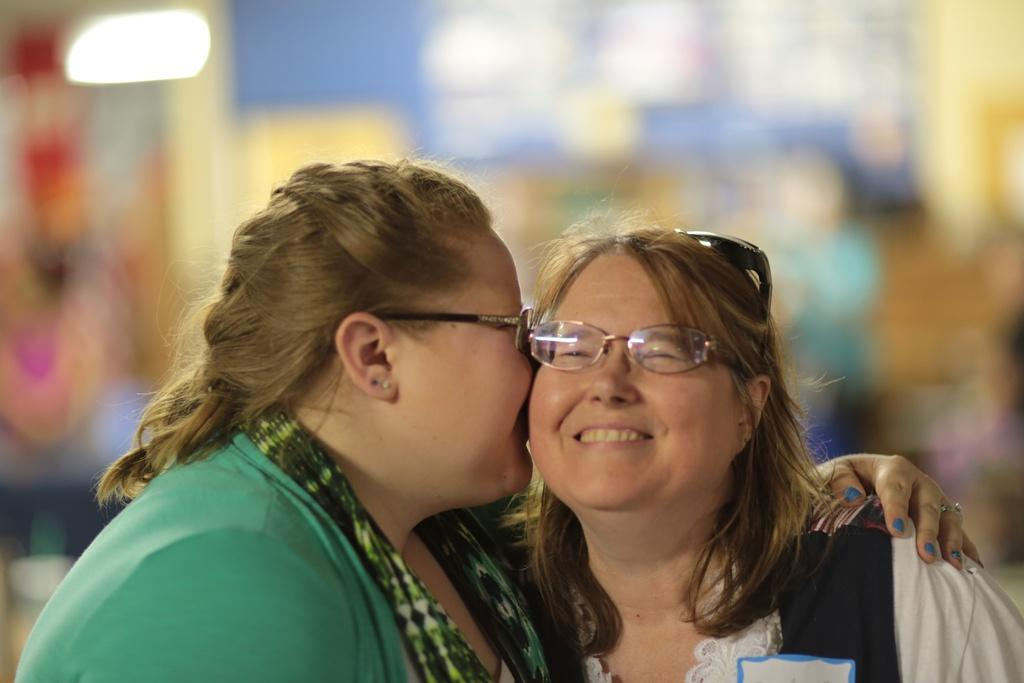Who is present in the image? There are women in the image. What are the women doing in the image? The women are standing and smiling. Can you describe the background of the image? The background of the image is blurry. What type of pig can be seen in the image? There is no pig present in the image. Who is the representative of the group in the image? The image does not indicate a specific representative among the women. 